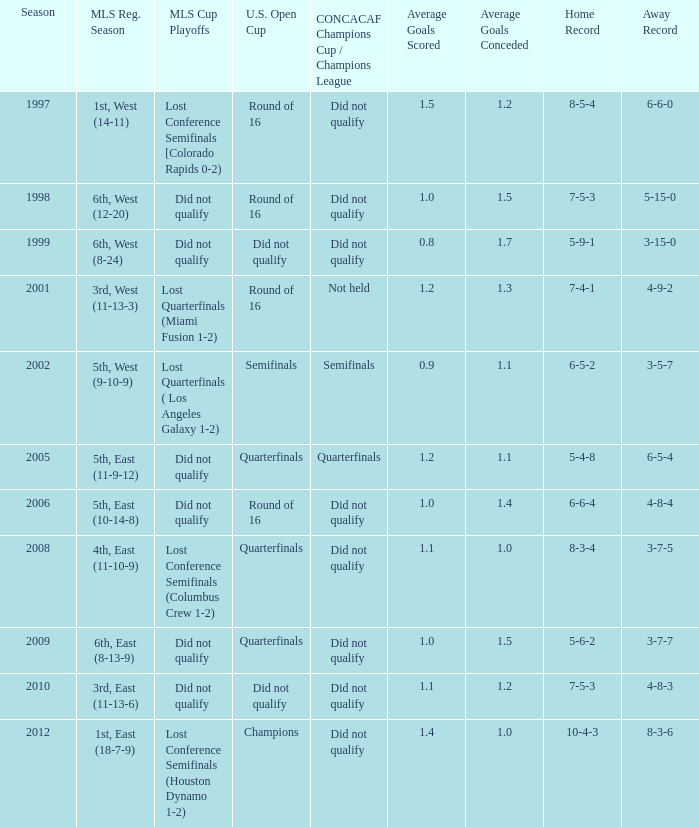What were the placements of the team in regular season when they reached quarterfinals in the U.S. Open Cup but did not qualify for the Concaf Champions Cup? 4th, East (11-10-9), 6th, East (8-13-9). 